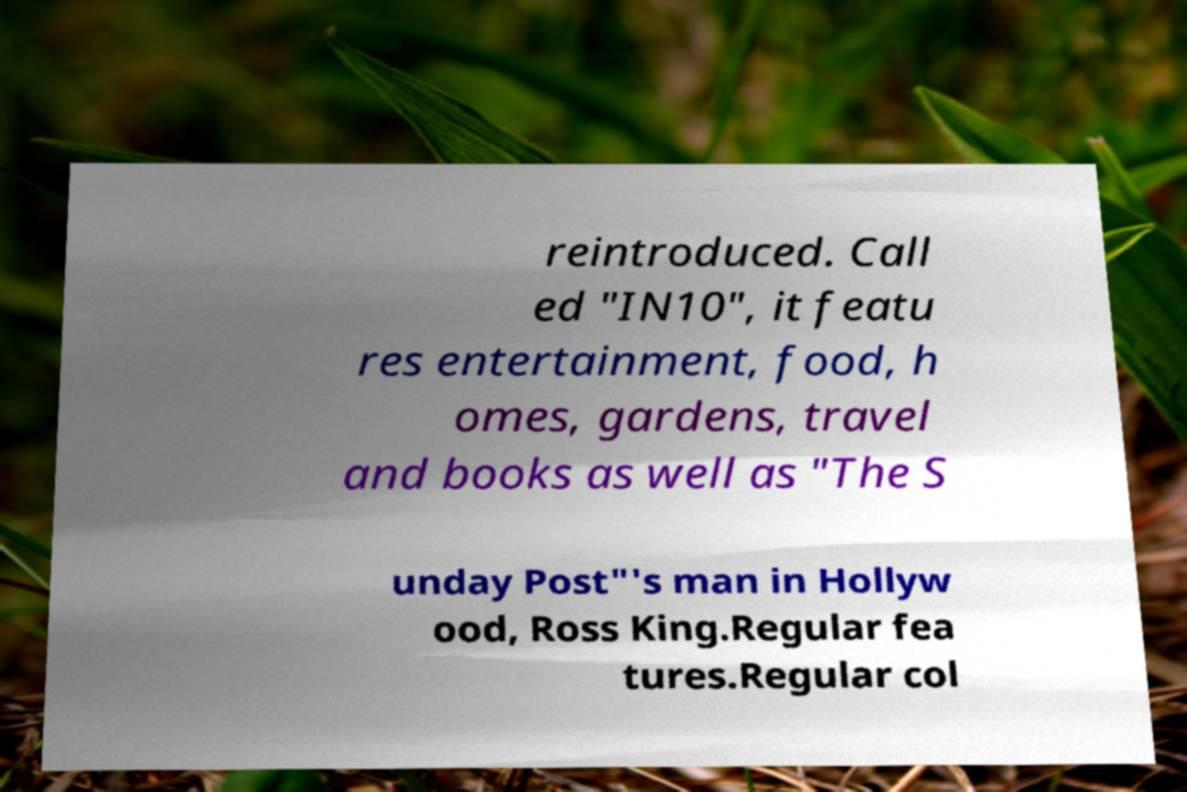I need the written content from this picture converted into text. Can you do that? reintroduced. Call ed "IN10", it featu res entertainment, food, h omes, gardens, travel and books as well as "The S unday Post"'s man in Hollyw ood, Ross King.Regular fea tures.Regular col 